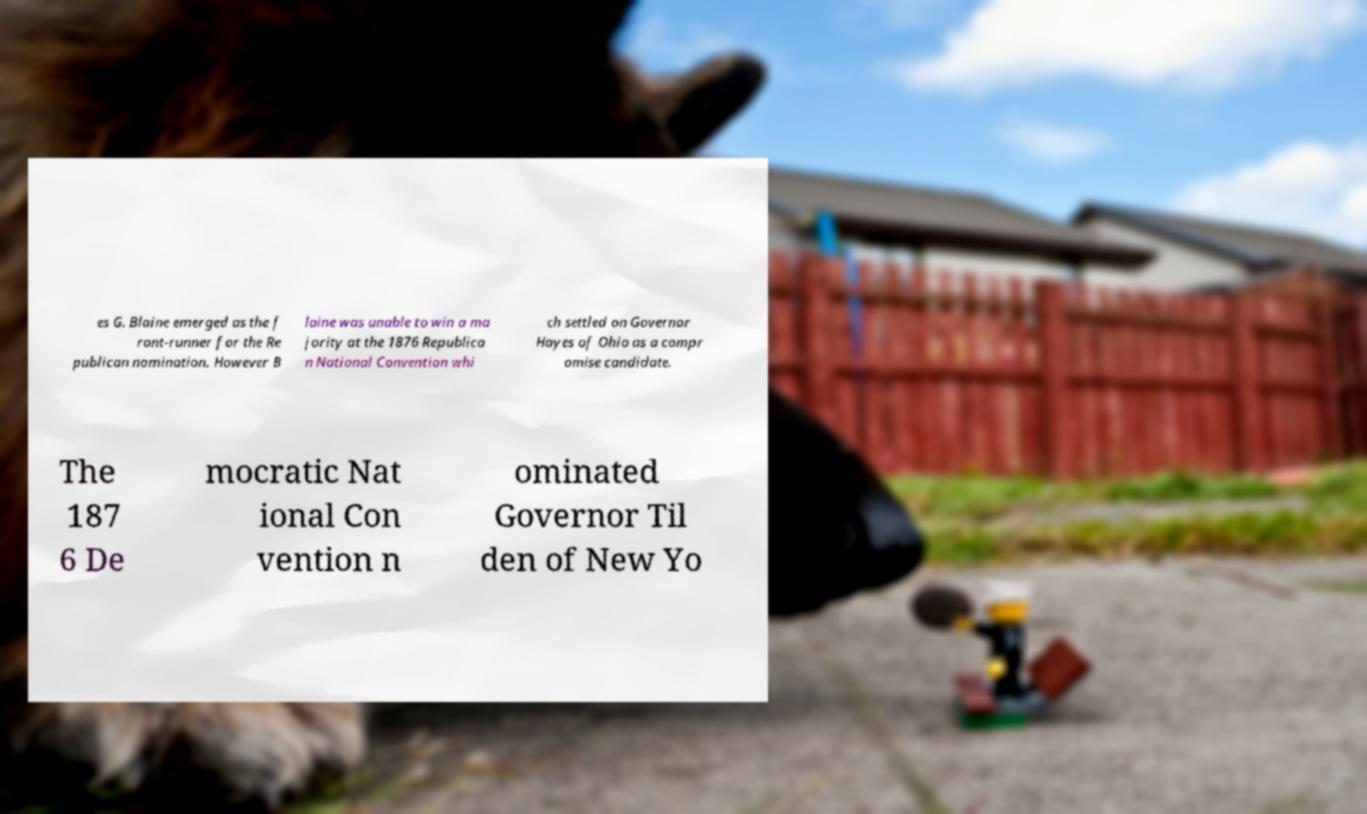For documentation purposes, I need the text within this image transcribed. Could you provide that? es G. Blaine emerged as the f ront-runner for the Re publican nomination. However B laine was unable to win a ma jority at the 1876 Republica n National Convention whi ch settled on Governor Hayes of Ohio as a compr omise candidate. The 187 6 De mocratic Nat ional Con vention n ominated Governor Til den of New Yo 